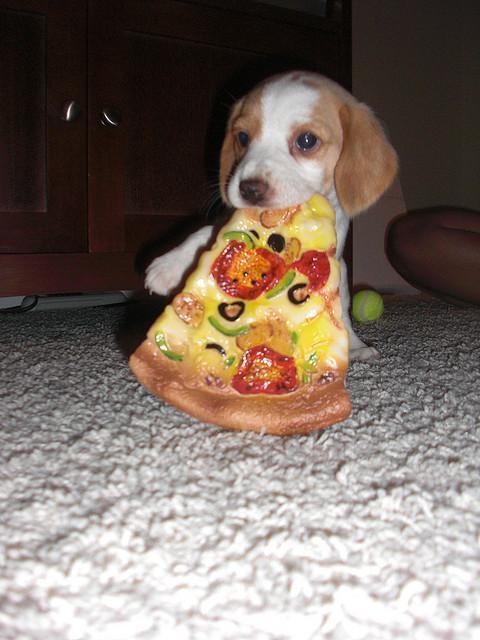What is the dog doing with the thing in its mouth?
Pick the right solution, then justify: 'Answer: answer
Rationale: rationale.'
Options: Vomiting, eating, playing, choking. Answer: playing.
Rationale: The dog seems to be eating the slice of pizza shown here. 